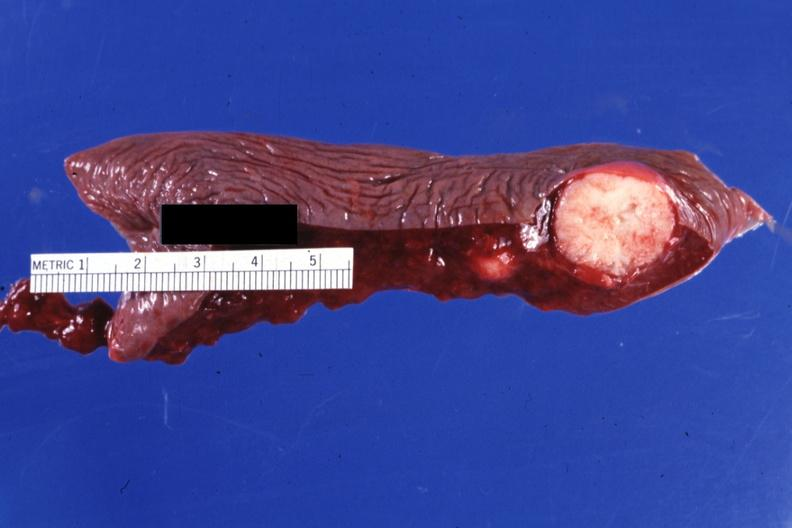what is present?
Answer the question using a single word or phrase. Spleen 